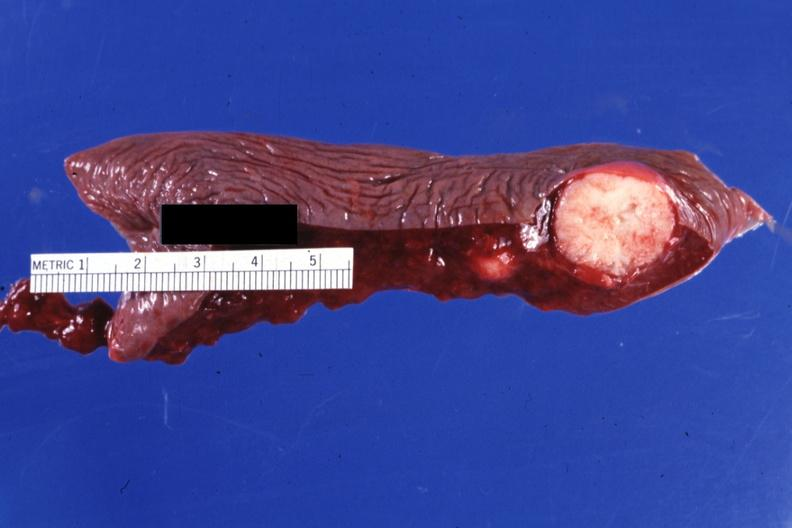what is present?
Answer the question using a single word or phrase. Spleen 